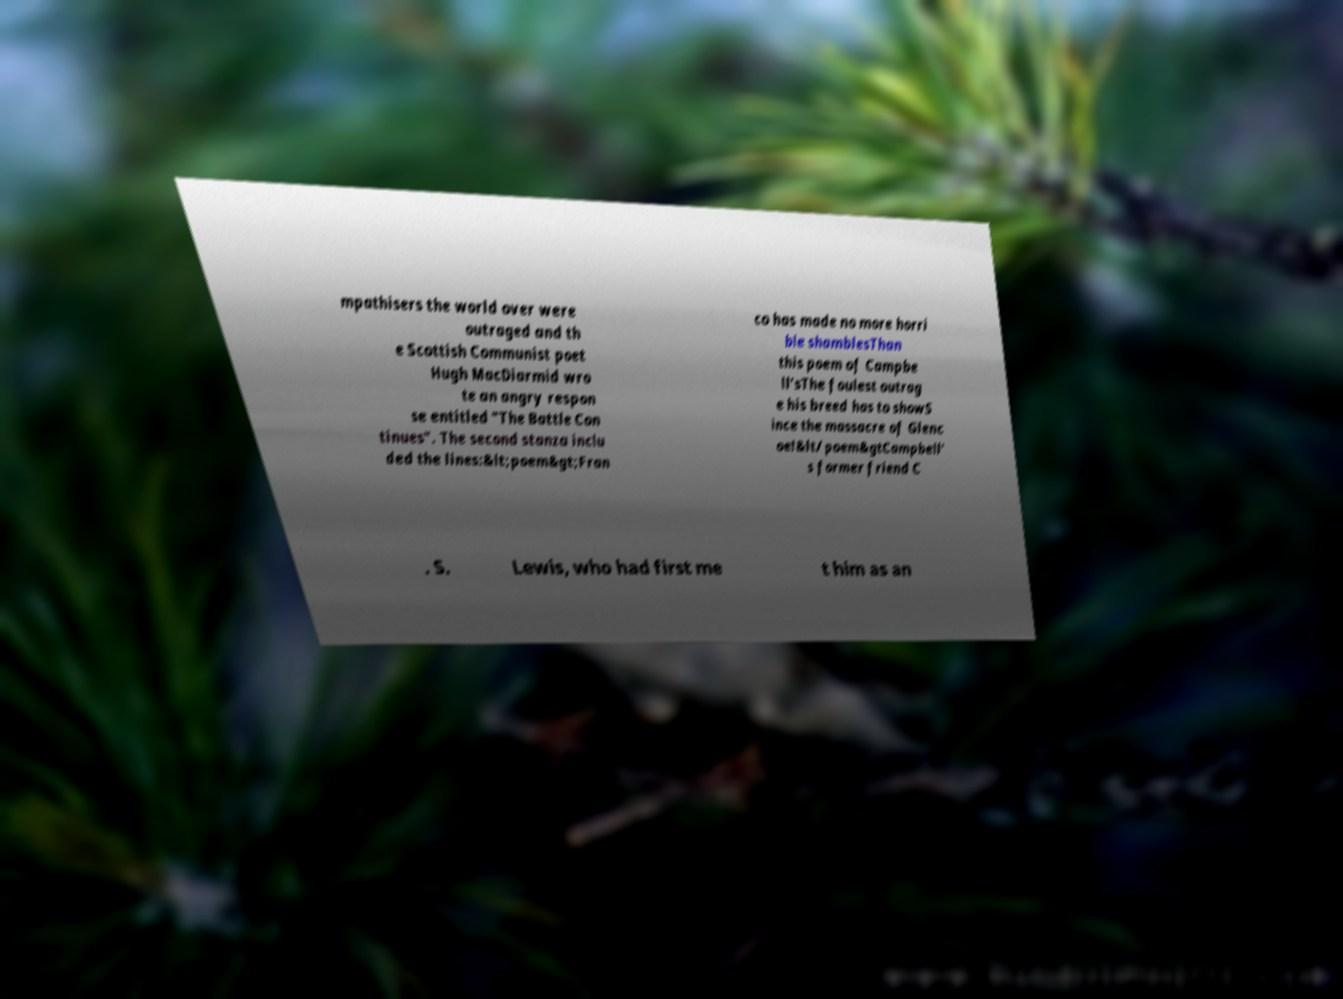There's text embedded in this image that I need extracted. Can you transcribe it verbatim? mpathisers the world over were outraged and th e Scottish Communist poet Hugh MacDiarmid wro te an angry respon se entitled "The Battle Con tinues". The second stanza inclu ded the lines:&lt;poem&gt;Fran co has made no more horri ble shamblesThan this poem of Campbe ll'sThe foulest outrag e his breed has to showS ince the massacre of Glenc oe!&lt/poem&gtCampbell' s former friend C . S. Lewis, who had first me t him as an 